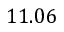<formula> <loc_0><loc_0><loc_500><loc_500>1 1 . 0 6</formula> 